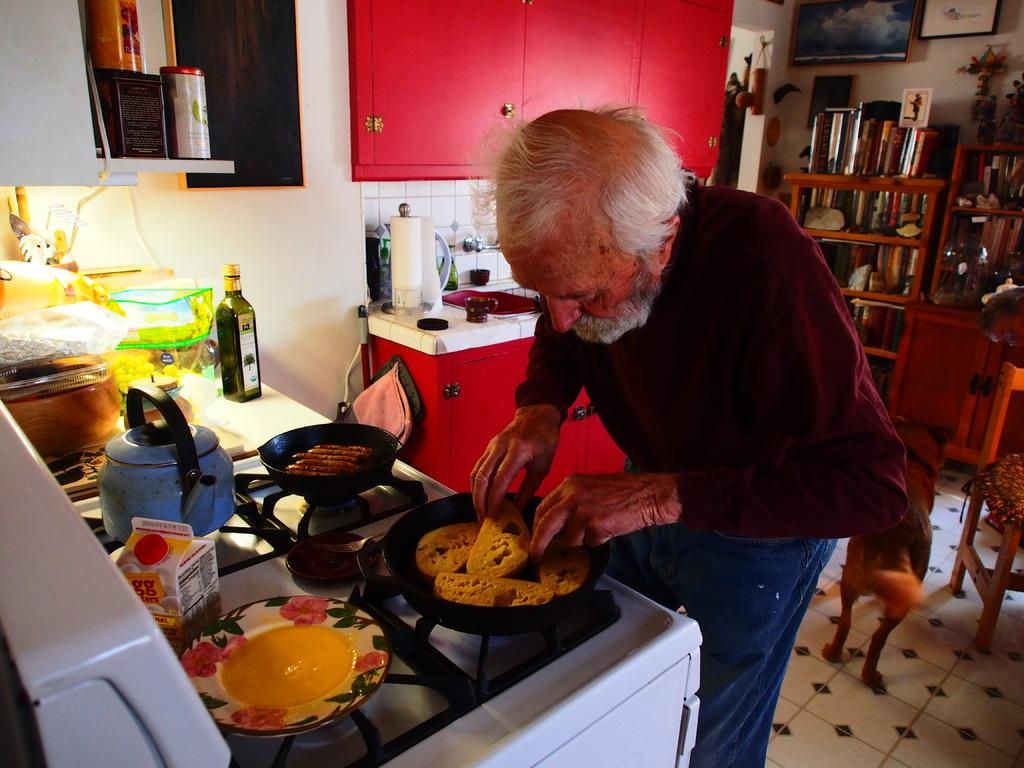What type of room is shown in the image? The image depicts a kitchen. What is the old man doing in the kitchen? The old man is preparing food in the kitchen. What can be seen on the kitchen platform? There are objects on the kitchen platform. What is used for cooking in the kitchen? A stove is present in the kitchen. Where are additional kitchen items stored? There is a wooden cupboard with objects in the kitchen. What type of yarn is being used to decorate the park in the image? There is no park or yarn present in the image; it is a kitchen scene with an old man preparing food. 